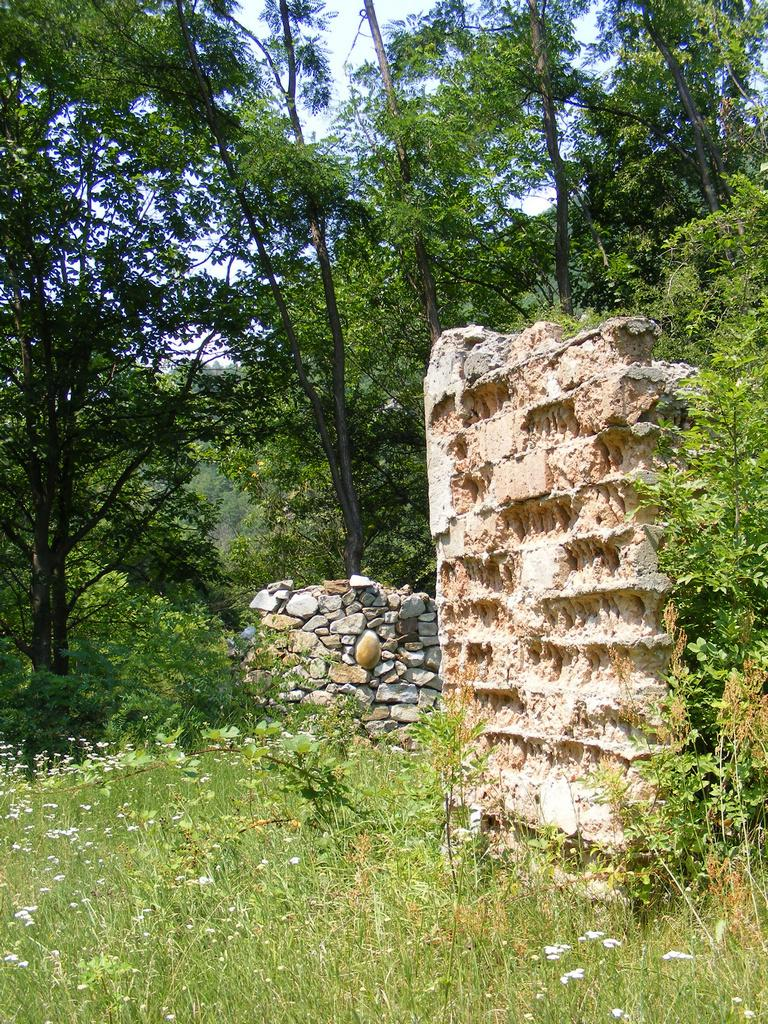What type of vegetation is present in the image? There are green trees in the image. What type of structure can be seen in the image? There is a stone wall in the image. What is the natural object located in the image? There is a rock in the image. What color is the sky in the image? The sky is blue in color. What type of comfort can be found in the image? There is no reference to comfort in the image, as it features green trees, a stone wall, a rock, and a blue sky. What fictional character is present in the image? There is no fictional character present in the image; it features natural elements and a stone wall. 